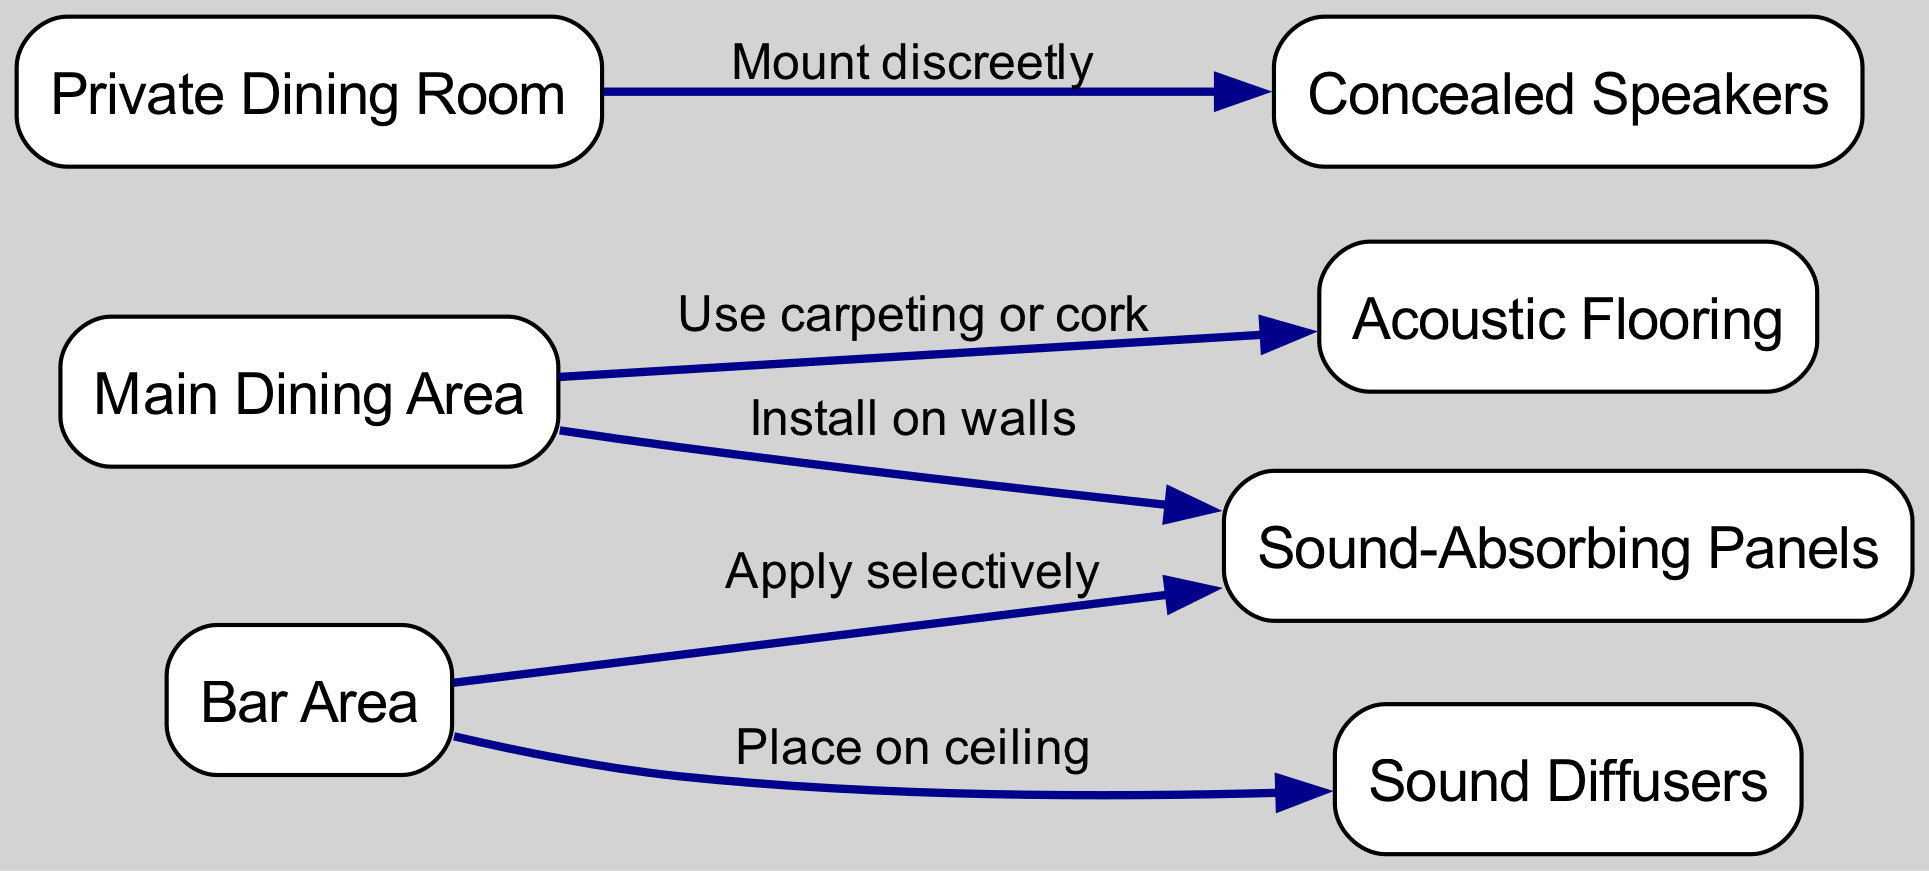What is the main area depicted in the diagram? The diagram identifies several areas; however, the "Main Dining Area" is explicitly labeled as a significant node in the diagram.
Answer: Main Dining Area How many nodes are present in the diagram? By counting the distinct labeled elements or areas in the graphical representation, there are a total of 7 nodes listed.
Answer: 7 Which area has sound-absorbing panels installed on its walls? The diagram specifies that sound-absorbing panels are to be installed on the walls of the "Main Dining Area," indicating a direct connection.
Answer: Main Dining Area Where are the sound diffusers placed? The diagram indicates that sound diffusers are to be placed on the ceiling of the "Bar Area," establishing a clear positioning.
Answer: Bar Area What is used as flooring in the main dining area? The diagram specifies that the flooring in the "Main Dining Area" should be carpeting or cork, indicating the type of acoustic treatment suggested.
Answer: Carpeting or cork Which area has discreetly mounted speakers? According to the diagram, the "Private Dining Room" has discreetly mounted speakers, highlighting its specific acoustic feature.
Answer: Private Dining Room In which area are sound-absorbing panels applied selectively? The diagram indicates that sound-absorbing panels are to be applied selectively in the "Bar Area," showing targeted acoustic treatment there.
Answer: Bar Area What type of flooring is suggested for the bar area? The diagram does not specify unique flooring for the bar area, which means it follows the general suggestions for areas where sound absorption is needed; hence, it remains unspecified in this context.
Answer: Not specified How many edges are used to connect the nodes? Counting the lines connecting all the nodes provides a total of 5 edges in the diagram.
Answer: 5 